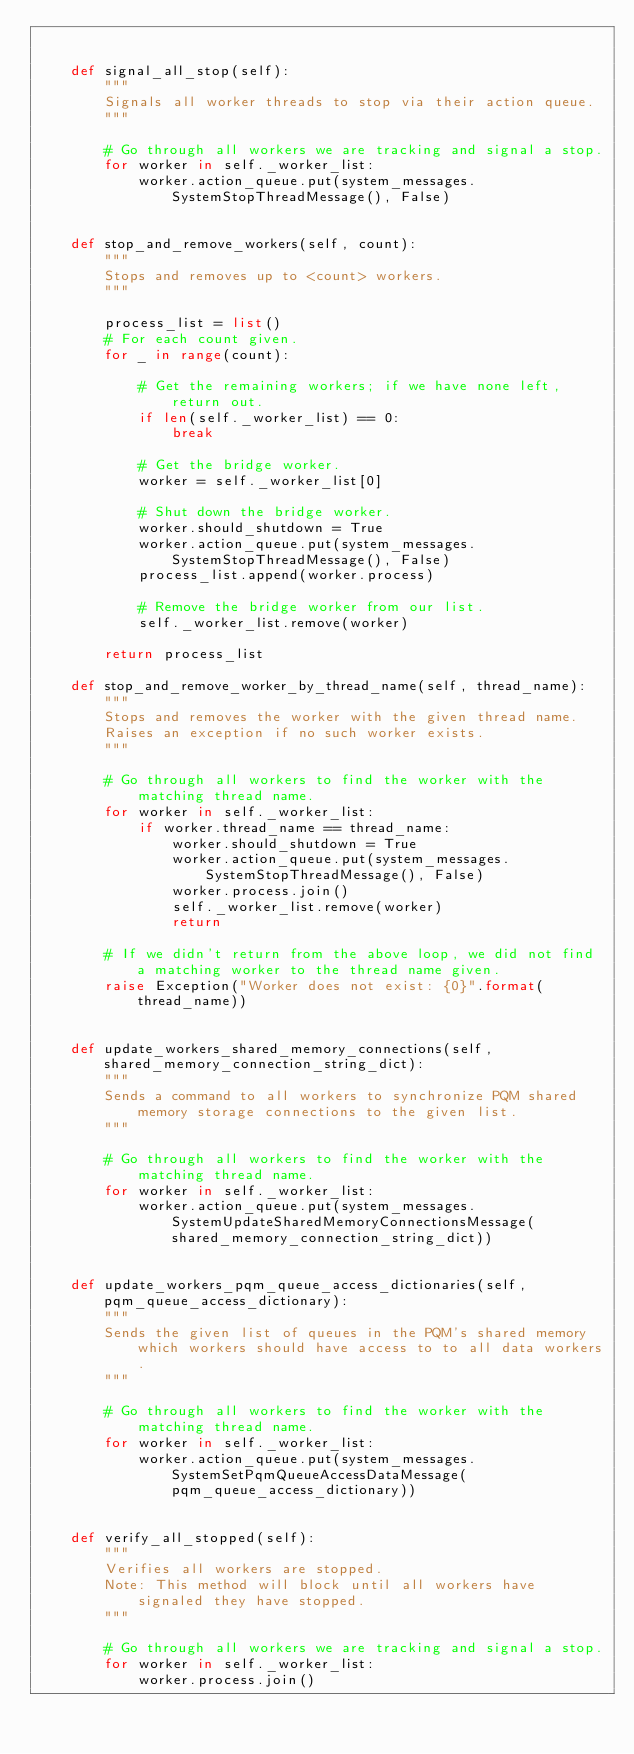Convert code to text. <code><loc_0><loc_0><loc_500><loc_500><_Python_>

    def signal_all_stop(self):
        """
        Signals all worker threads to stop via their action queue.
        """
        
        # Go through all workers we are tracking and signal a stop.
        for worker in self._worker_list:
            worker.action_queue.put(system_messages.SystemStopThreadMessage(), False)
            

    def stop_and_remove_workers(self, count):
        """
        Stops and removes up to <count> workers.
        """
        
        process_list = list()
        # For each count given.
        for _ in range(count):
            
            # Get the remaining workers; if we have none left, return out.
            if len(self._worker_list) == 0:
                break
            
            # Get the bridge worker.
            worker = self._worker_list[0]
            
            # Shut down the bridge worker.                        
            worker.should_shutdown = True
            worker.action_queue.put(system_messages.SystemStopThreadMessage(), False)
            process_list.append(worker.process)
            
            # Remove the bridge worker from our list.
            self._worker_list.remove(worker)

        return process_list

    def stop_and_remove_worker_by_thread_name(self, thread_name):
        """
        Stops and removes the worker with the given thread name.
        Raises an exception if no such worker exists.
        """
        
        # Go through all workers to find the worker with the matching thread name.
        for worker in self._worker_list:
            if worker.thread_name == thread_name:                        
                worker.should_shutdown = True
                worker.action_queue.put(system_messages.SystemStopThreadMessage(), False)
                worker.process.join()
                self._worker_list.remove(worker)
                return
                
        # If we didn't return from the above loop, we did not find a matching worker to the thread name given.
        raise Exception("Worker does not exist: {0}".format(thread_name))
                
                
    def update_workers_shared_memory_connections(self, shared_memory_connection_string_dict):
        """
        Sends a command to all workers to synchronize PQM shared memory storage connections to the given list.
        """
        
        # Go through all workers to find the worker with the matching thread name.
        for worker in self._worker_list:
            worker.action_queue.put(system_messages.SystemUpdateSharedMemoryConnectionsMessage(shared_memory_connection_string_dict))
                
                
    def update_workers_pqm_queue_access_dictionaries(self, pqm_queue_access_dictionary):
        """
        Sends the given list of queues in the PQM's shared memory which workers should have access to to all data workers.
        """
        
        # Go through all workers to find the worker with the matching thread name.
        for worker in self._worker_list:
            worker.action_queue.put(system_messages.SystemSetPqmQueueAccessDataMessage(pqm_queue_access_dictionary))


    def verify_all_stopped(self):
        """
        Verifies all workers are stopped.
        Note: This method will block until all workers have signaled they have stopped.  
        """
        
        # Go through all workers we are tracking and signal a stop.
        for worker in self._worker_list:
            worker.process.join()</code> 